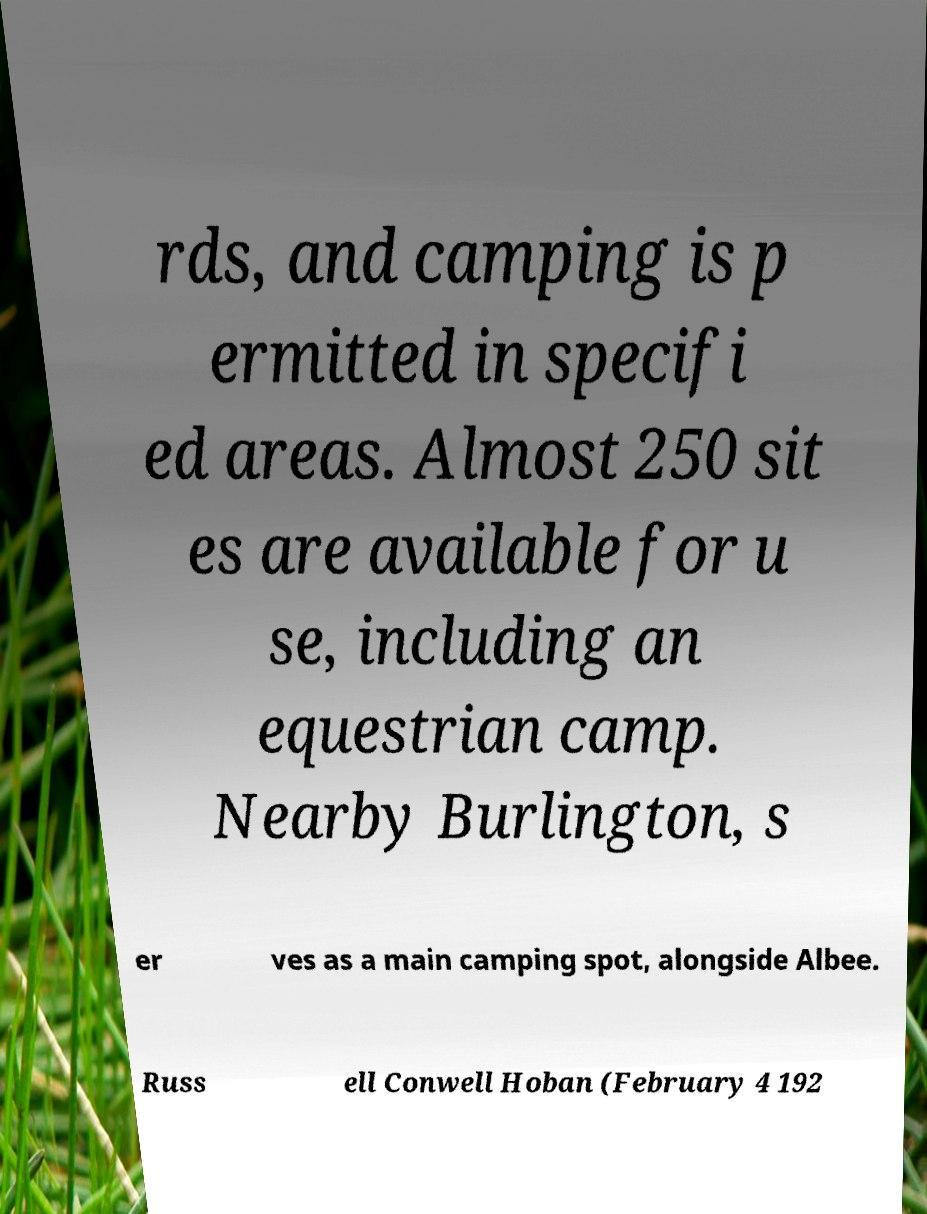Can you read and provide the text displayed in the image?This photo seems to have some interesting text. Can you extract and type it out for me? rds, and camping is p ermitted in specifi ed areas. Almost 250 sit es are available for u se, including an equestrian camp. Nearby Burlington, s er ves as a main camping spot, alongside Albee. Russ ell Conwell Hoban (February 4 192 